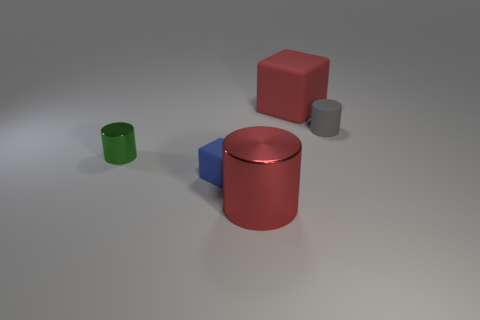Subtract all big red metal cylinders. How many cylinders are left? 2 Add 2 big cyan cubes. How many objects exist? 7 Subtract all cylinders. How many objects are left? 2 Add 3 large red rubber things. How many large red rubber things exist? 4 Subtract 0 gray spheres. How many objects are left? 5 Subtract all brown rubber cubes. Subtract all tiny cylinders. How many objects are left? 3 Add 1 big red rubber things. How many big red rubber things are left? 2 